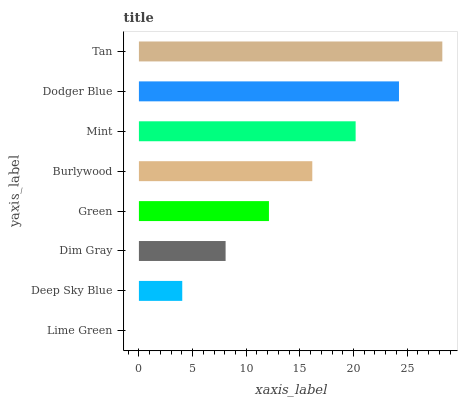Is Lime Green the minimum?
Answer yes or no. Yes. Is Tan the maximum?
Answer yes or no. Yes. Is Deep Sky Blue the minimum?
Answer yes or no. No. Is Deep Sky Blue the maximum?
Answer yes or no. No. Is Deep Sky Blue greater than Lime Green?
Answer yes or no. Yes. Is Lime Green less than Deep Sky Blue?
Answer yes or no. Yes. Is Lime Green greater than Deep Sky Blue?
Answer yes or no. No. Is Deep Sky Blue less than Lime Green?
Answer yes or no. No. Is Burlywood the high median?
Answer yes or no. Yes. Is Green the low median?
Answer yes or no. Yes. Is Dodger Blue the high median?
Answer yes or no. No. Is Lime Green the low median?
Answer yes or no. No. 